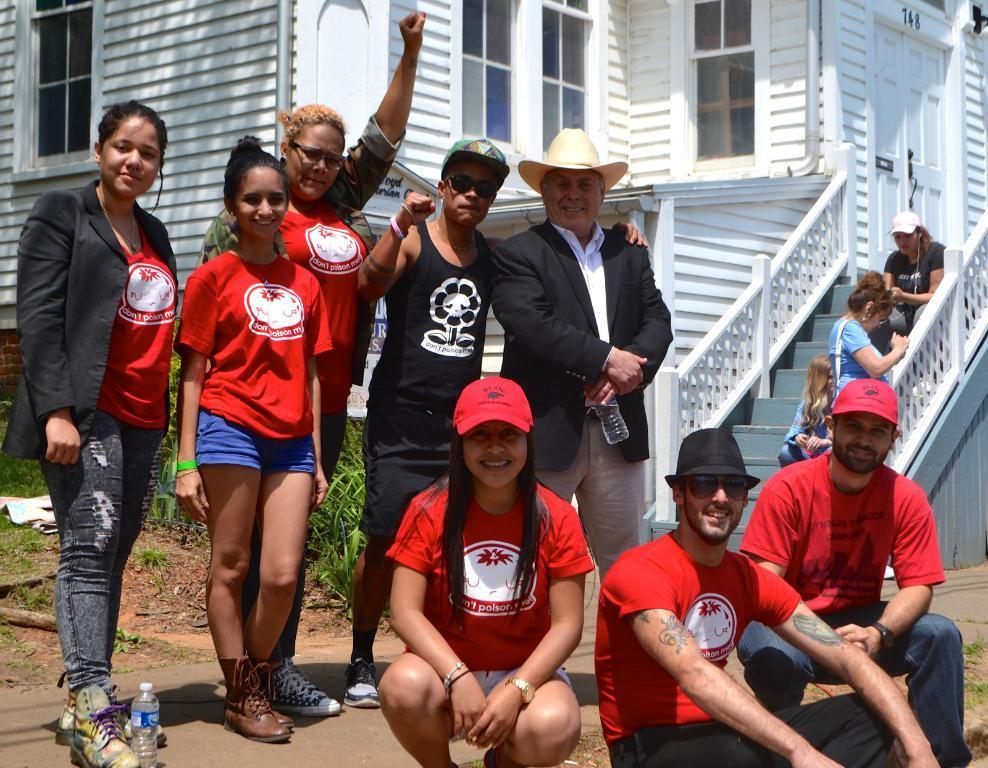Describe this image in one or two sentences. In the image there are a group of people in the foreground, behind them there are plants and a house. 